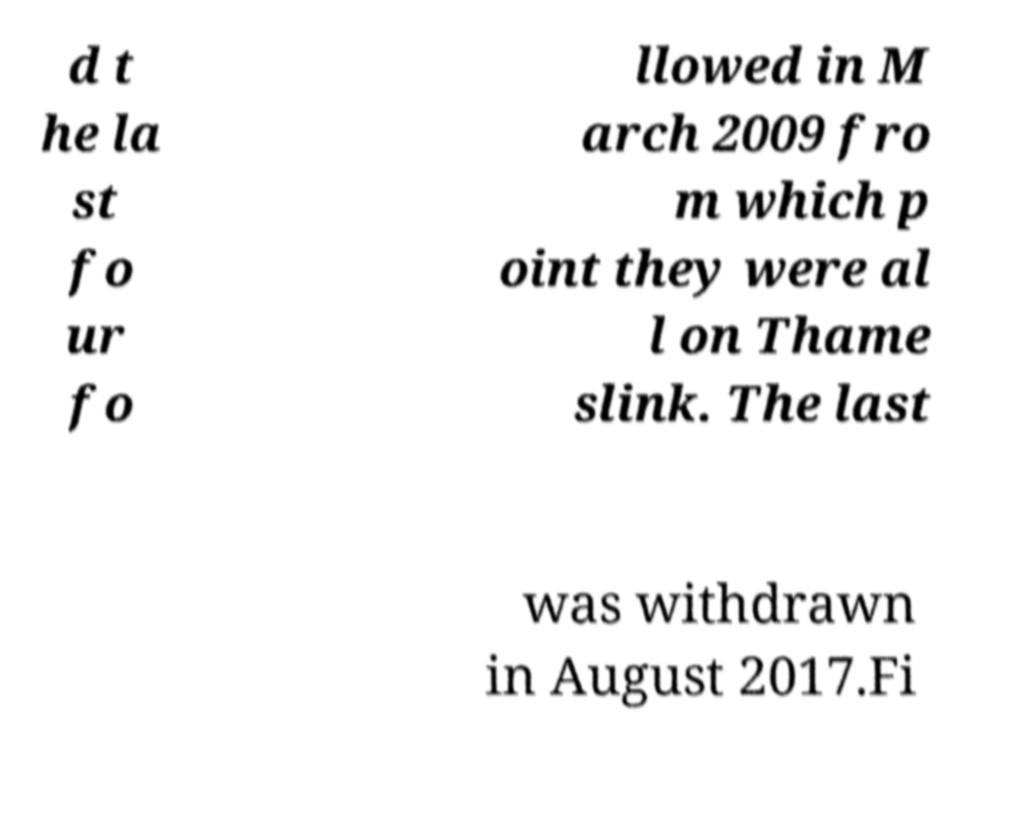I need the written content from this picture converted into text. Can you do that? d t he la st fo ur fo llowed in M arch 2009 fro m which p oint they were al l on Thame slink. The last was withdrawn in August 2017.Fi 